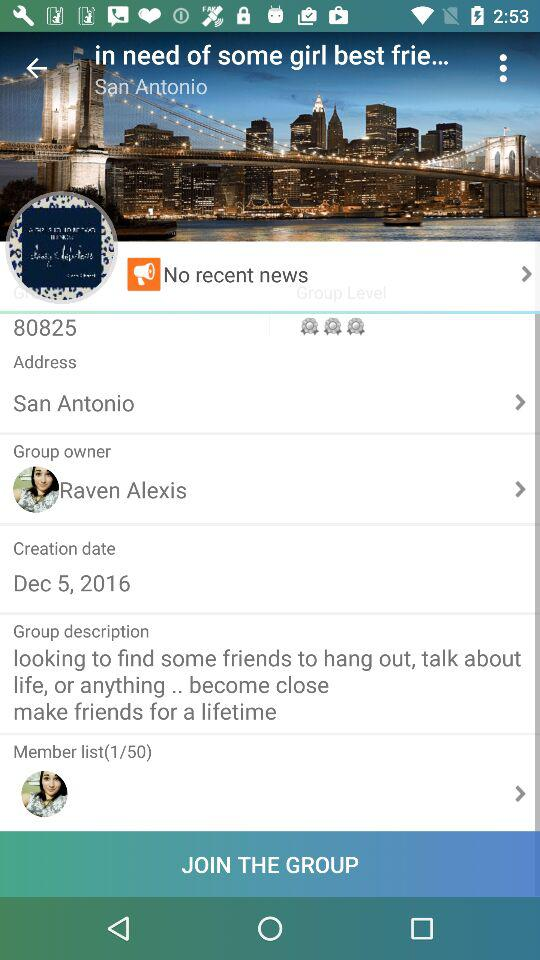Who is the group owner? The group owner is "Raven Alexis". 